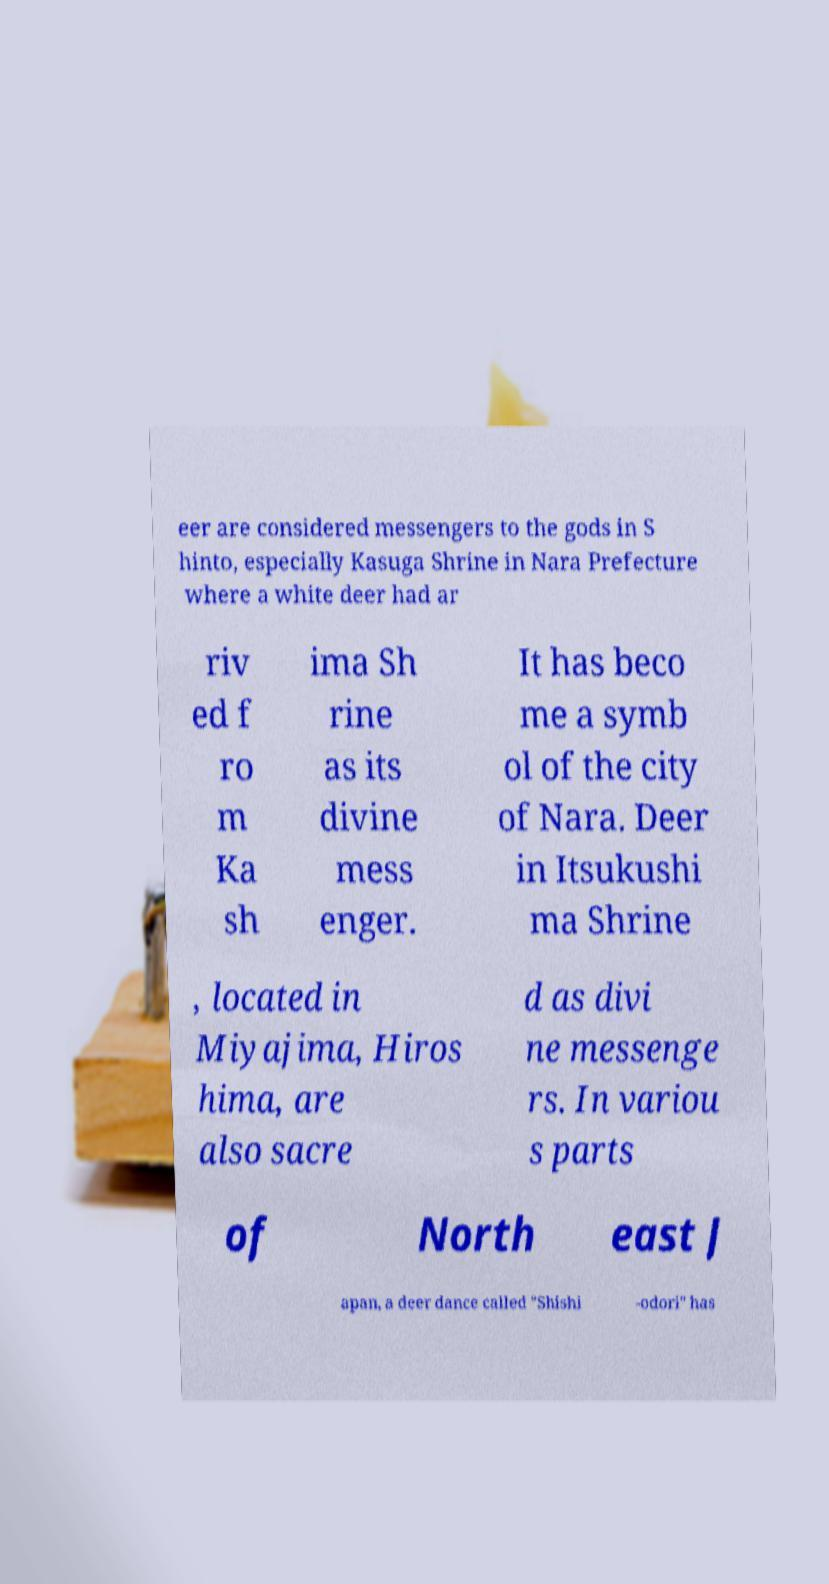I need the written content from this picture converted into text. Can you do that? eer are considered messengers to the gods in S hinto, especially Kasuga Shrine in Nara Prefecture where a white deer had ar riv ed f ro m Ka sh ima Sh rine as its divine mess enger. It has beco me a symb ol of the city of Nara. Deer in Itsukushi ma Shrine , located in Miyajima, Hiros hima, are also sacre d as divi ne messenge rs. In variou s parts of North east J apan, a deer dance called "Shishi -odori" has 